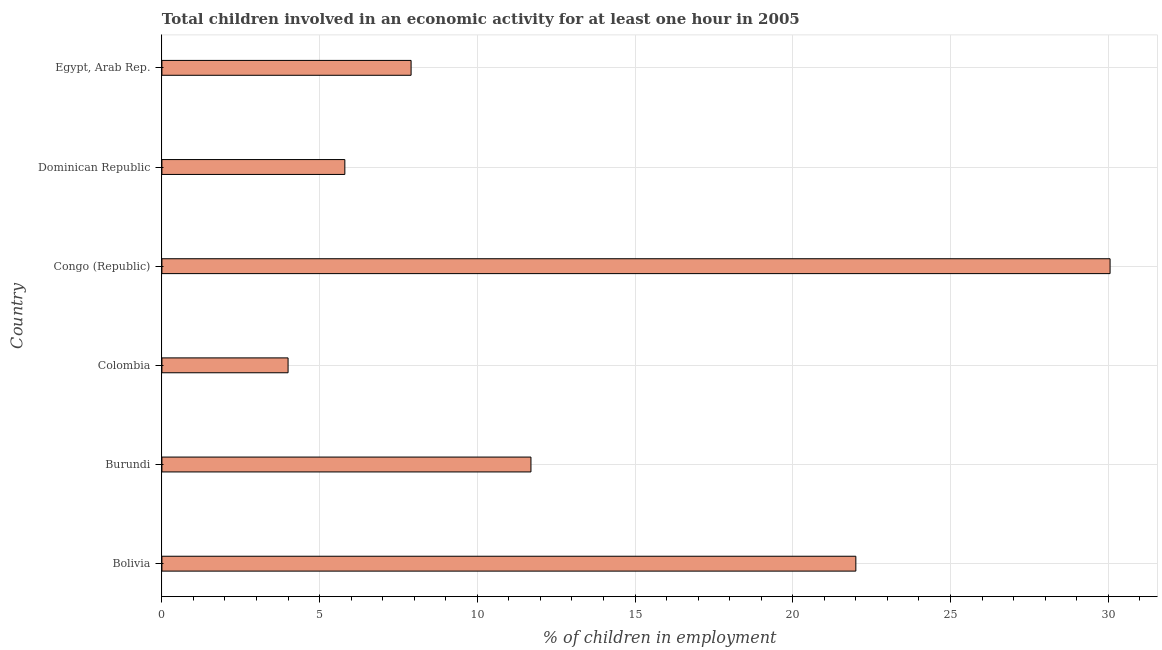Does the graph contain grids?
Make the answer very short. Yes. What is the title of the graph?
Make the answer very short. Total children involved in an economic activity for at least one hour in 2005. What is the label or title of the X-axis?
Ensure brevity in your answer.  % of children in employment. Across all countries, what is the maximum percentage of children in employment?
Your answer should be very brief. 30.06. Across all countries, what is the minimum percentage of children in employment?
Keep it short and to the point. 4. In which country was the percentage of children in employment maximum?
Provide a short and direct response. Congo (Republic). What is the sum of the percentage of children in employment?
Ensure brevity in your answer.  81.46. What is the average percentage of children in employment per country?
Offer a terse response. 13.58. What is the median percentage of children in employment?
Keep it short and to the point. 9.8. In how many countries, is the percentage of children in employment greater than 9 %?
Give a very brief answer. 3. What is the ratio of the percentage of children in employment in Burundi to that in Dominican Republic?
Keep it short and to the point. 2.02. Is the difference between the percentage of children in employment in Colombia and Congo (Republic) greater than the difference between any two countries?
Ensure brevity in your answer.  Yes. What is the difference between the highest and the second highest percentage of children in employment?
Provide a short and direct response. 8.06. What is the difference between the highest and the lowest percentage of children in employment?
Your answer should be very brief. 26.06. In how many countries, is the percentage of children in employment greater than the average percentage of children in employment taken over all countries?
Make the answer very short. 2. How many bars are there?
Keep it short and to the point. 6. What is the difference between two consecutive major ticks on the X-axis?
Ensure brevity in your answer.  5. What is the % of children in employment in Colombia?
Ensure brevity in your answer.  4. What is the % of children in employment in Congo (Republic)?
Make the answer very short. 30.06. What is the difference between the % of children in employment in Bolivia and Congo (Republic)?
Ensure brevity in your answer.  -8.06. What is the difference between the % of children in employment in Bolivia and Dominican Republic?
Keep it short and to the point. 16.2. What is the difference between the % of children in employment in Burundi and Colombia?
Offer a very short reply. 7.7. What is the difference between the % of children in employment in Burundi and Congo (Republic)?
Provide a short and direct response. -18.36. What is the difference between the % of children in employment in Burundi and Dominican Republic?
Give a very brief answer. 5.9. What is the difference between the % of children in employment in Burundi and Egypt, Arab Rep.?
Keep it short and to the point. 3.8. What is the difference between the % of children in employment in Colombia and Congo (Republic)?
Your response must be concise. -26.06. What is the difference between the % of children in employment in Colombia and Egypt, Arab Rep.?
Provide a succinct answer. -3.9. What is the difference between the % of children in employment in Congo (Republic) and Dominican Republic?
Offer a terse response. 24.26. What is the difference between the % of children in employment in Congo (Republic) and Egypt, Arab Rep.?
Provide a succinct answer. 22.16. What is the ratio of the % of children in employment in Bolivia to that in Burundi?
Your response must be concise. 1.88. What is the ratio of the % of children in employment in Bolivia to that in Congo (Republic)?
Give a very brief answer. 0.73. What is the ratio of the % of children in employment in Bolivia to that in Dominican Republic?
Offer a terse response. 3.79. What is the ratio of the % of children in employment in Bolivia to that in Egypt, Arab Rep.?
Give a very brief answer. 2.79. What is the ratio of the % of children in employment in Burundi to that in Colombia?
Make the answer very short. 2.92. What is the ratio of the % of children in employment in Burundi to that in Congo (Republic)?
Your answer should be compact. 0.39. What is the ratio of the % of children in employment in Burundi to that in Dominican Republic?
Give a very brief answer. 2.02. What is the ratio of the % of children in employment in Burundi to that in Egypt, Arab Rep.?
Keep it short and to the point. 1.48. What is the ratio of the % of children in employment in Colombia to that in Congo (Republic)?
Keep it short and to the point. 0.13. What is the ratio of the % of children in employment in Colombia to that in Dominican Republic?
Your response must be concise. 0.69. What is the ratio of the % of children in employment in Colombia to that in Egypt, Arab Rep.?
Your answer should be compact. 0.51. What is the ratio of the % of children in employment in Congo (Republic) to that in Dominican Republic?
Your response must be concise. 5.18. What is the ratio of the % of children in employment in Congo (Republic) to that in Egypt, Arab Rep.?
Your response must be concise. 3.81. What is the ratio of the % of children in employment in Dominican Republic to that in Egypt, Arab Rep.?
Make the answer very short. 0.73. 